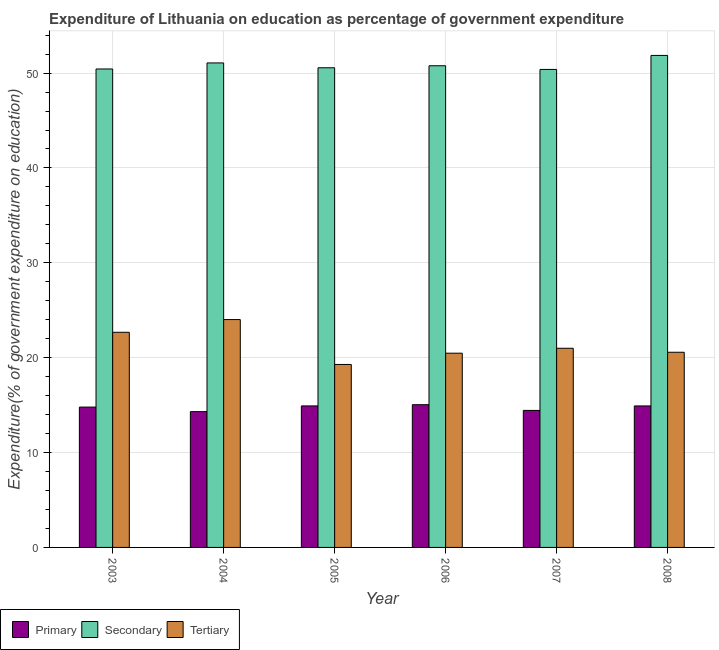How many groups of bars are there?
Ensure brevity in your answer.  6. Are the number of bars per tick equal to the number of legend labels?
Your answer should be compact. Yes. How many bars are there on the 2nd tick from the left?
Keep it short and to the point. 3. How many bars are there on the 1st tick from the right?
Your answer should be compact. 3. What is the expenditure on tertiary education in 2003?
Provide a short and direct response. 22.68. Across all years, what is the maximum expenditure on secondary education?
Provide a short and direct response. 51.86. Across all years, what is the minimum expenditure on secondary education?
Provide a succinct answer. 50.39. In which year was the expenditure on tertiary education minimum?
Make the answer very short. 2005. What is the total expenditure on primary education in the graph?
Provide a succinct answer. 88.43. What is the difference between the expenditure on tertiary education in 2003 and that in 2005?
Your response must be concise. 3.39. What is the difference between the expenditure on secondary education in 2007 and the expenditure on primary education in 2005?
Keep it short and to the point. -0.17. What is the average expenditure on secondary education per year?
Provide a succinct answer. 50.85. In how many years, is the expenditure on primary education greater than 10 %?
Offer a terse response. 6. What is the ratio of the expenditure on secondary education in 2006 to that in 2008?
Your response must be concise. 0.98. Is the expenditure on secondary education in 2007 less than that in 2008?
Give a very brief answer. Yes. Is the difference between the expenditure on primary education in 2005 and 2006 greater than the difference between the expenditure on secondary education in 2005 and 2006?
Provide a succinct answer. No. What is the difference between the highest and the second highest expenditure on primary education?
Make the answer very short. 0.13. What is the difference between the highest and the lowest expenditure on primary education?
Provide a succinct answer. 0.73. In how many years, is the expenditure on primary education greater than the average expenditure on primary education taken over all years?
Offer a very short reply. 4. Is the sum of the expenditure on secondary education in 2006 and 2007 greater than the maximum expenditure on primary education across all years?
Your answer should be very brief. Yes. What does the 1st bar from the left in 2003 represents?
Your answer should be very brief. Primary. What does the 3rd bar from the right in 2003 represents?
Your response must be concise. Primary. How many bars are there?
Your answer should be very brief. 18. Are the values on the major ticks of Y-axis written in scientific E-notation?
Give a very brief answer. No. How many legend labels are there?
Make the answer very short. 3. How are the legend labels stacked?
Ensure brevity in your answer.  Horizontal. What is the title of the graph?
Make the answer very short. Expenditure of Lithuania on education as percentage of government expenditure. What is the label or title of the Y-axis?
Provide a succinct answer. Expenditure(% of government expenditure on education). What is the Expenditure(% of government expenditure on education) of Primary in 2003?
Give a very brief answer. 14.79. What is the Expenditure(% of government expenditure on education) of Secondary in 2003?
Offer a very short reply. 50.43. What is the Expenditure(% of government expenditure on education) in Tertiary in 2003?
Give a very brief answer. 22.68. What is the Expenditure(% of government expenditure on education) in Primary in 2004?
Your response must be concise. 14.31. What is the Expenditure(% of government expenditure on education) of Secondary in 2004?
Your answer should be compact. 51.07. What is the Expenditure(% of government expenditure on education) of Tertiary in 2004?
Keep it short and to the point. 24.02. What is the Expenditure(% of government expenditure on education) of Primary in 2005?
Offer a terse response. 14.92. What is the Expenditure(% of government expenditure on education) in Secondary in 2005?
Provide a short and direct response. 50.56. What is the Expenditure(% of government expenditure on education) of Tertiary in 2005?
Keep it short and to the point. 19.29. What is the Expenditure(% of government expenditure on education) of Primary in 2006?
Offer a terse response. 15.04. What is the Expenditure(% of government expenditure on education) of Secondary in 2006?
Offer a terse response. 50.77. What is the Expenditure(% of government expenditure on education) in Tertiary in 2006?
Your answer should be very brief. 20.47. What is the Expenditure(% of government expenditure on education) in Primary in 2007?
Keep it short and to the point. 14.44. What is the Expenditure(% of government expenditure on education) in Secondary in 2007?
Ensure brevity in your answer.  50.39. What is the Expenditure(% of government expenditure on education) in Tertiary in 2007?
Provide a succinct answer. 20.99. What is the Expenditure(% of government expenditure on education) of Primary in 2008?
Your answer should be compact. 14.92. What is the Expenditure(% of government expenditure on education) of Secondary in 2008?
Give a very brief answer. 51.86. What is the Expenditure(% of government expenditure on education) of Tertiary in 2008?
Your response must be concise. 20.57. Across all years, what is the maximum Expenditure(% of government expenditure on education) of Primary?
Your answer should be compact. 15.04. Across all years, what is the maximum Expenditure(% of government expenditure on education) of Secondary?
Your answer should be very brief. 51.86. Across all years, what is the maximum Expenditure(% of government expenditure on education) of Tertiary?
Your answer should be compact. 24.02. Across all years, what is the minimum Expenditure(% of government expenditure on education) in Primary?
Your answer should be compact. 14.31. Across all years, what is the minimum Expenditure(% of government expenditure on education) of Secondary?
Provide a short and direct response. 50.39. Across all years, what is the minimum Expenditure(% of government expenditure on education) of Tertiary?
Offer a terse response. 19.29. What is the total Expenditure(% of government expenditure on education) in Primary in the graph?
Offer a terse response. 88.43. What is the total Expenditure(% of government expenditure on education) of Secondary in the graph?
Keep it short and to the point. 305.09. What is the total Expenditure(% of government expenditure on education) of Tertiary in the graph?
Make the answer very short. 128.02. What is the difference between the Expenditure(% of government expenditure on education) in Primary in 2003 and that in 2004?
Offer a terse response. 0.48. What is the difference between the Expenditure(% of government expenditure on education) in Secondary in 2003 and that in 2004?
Provide a short and direct response. -0.64. What is the difference between the Expenditure(% of government expenditure on education) of Tertiary in 2003 and that in 2004?
Offer a very short reply. -1.34. What is the difference between the Expenditure(% of government expenditure on education) in Primary in 2003 and that in 2005?
Offer a very short reply. -0.12. What is the difference between the Expenditure(% of government expenditure on education) in Secondary in 2003 and that in 2005?
Offer a terse response. -0.13. What is the difference between the Expenditure(% of government expenditure on education) of Tertiary in 2003 and that in 2005?
Make the answer very short. 3.39. What is the difference between the Expenditure(% of government expenditure on education) of Primary in 2003 and that in 2006?
Keep it short and to the point. -0.25. What is the difference between the Expenditure(% of government expenditure on education) of Secondary in 2003 and that in 2006?
Provide a short and direct response. -0.34. What is the difference between the Expenditure(% of government expenditure on education) in Tertiary in 2003 and that in 2006?
Provide a short and direct response. 2.2. What is the difference between the Expenditure(% of government expenditure on education) of Primary in 2003 and that in 2007?
Offer a terse response. 0.35. What is the difference between the Expenditure(% of government expenditure on education) of Secondary in 2003 and that in 2007?
Your answer should be compact. 0.05. What is the difference between the Expenditure(% of government expenditure on education) of Tertiary in 2003 and that in 2007?
Offer a very short reply. 1.68. What is the difference between the Expenditure(% of government expenditure on education) in Primary in 2003 and that in 2008?
Provide a short and direct response. -0.12. What is the difference between the Expenditure(% of government expenditure on education) in Secondary in 2003 and that in 2008?
Make the answer very short. -1.43. What is the difference between the Expenditure(% of government expenditure on education) in Tertiary in 2003 and that in 2008?
Keep it short and to the point. 2.1. What is the difference between the Expenditure(% of government expenditure on education) in Primary in 2004 and that in 2005?
Your answer should be very brief. -0.6. What is the difference between the Expenditure(% of government expenditure on education) in Secondary in 2004 and that in 2005?
Your answer should be very brief. 0.51. What is the difference between the Expenditure(% of government expenditure on education) of Tertiary in 2004 and that in 2005?
Ensure brevity in your answer.  4.73. What is the difference between the Expenditure(% of government expenditure on education) of Primary in 2004 and that in 2006?
Offer a very short reply. -0.73. What is the difference between the Expenditure(% of government expenditure on education) of Secondary in 2004 and that in 2006?
Keep it short and to the point. 0.3. What is the difference between the Expenditure(% of government expenditure on education) in Tertiary in 2004 and that in 2006?
Make the answer very short. 3.54. What is the difference between the Expenditure(% of government expenditure on education) in Primary in 2004 and that in 2007?
Give a very brief answer. -0.13. What is the difference between the Expenditure(% of government expenditure on education) of Secondary in 2004 and that in 2007?
Offer a very short reply. 0.68. What is the difference between the Expenditure(% of government expenditure on education) in Tertiary in 2004 and that in 2007?
Your answer should be compact. 3.02. What is the difference between the Expenditure(% of government expenditure on education) in Primary in 2004 and that in 2008?
Offer a terse response. -0.6. What is the difference between the Expenditure(% of government expenditure on education) of Secondary in 2004 and that in 2008?
Provide a short and direct response. -0.79. What is the difference between the Expenditure(% of government expenditure on education) in Tertiary in 2004 and that in 2008?
Give a very brief answer. 3.45. What is the difference between the Expenditure(% of government expenditure on education) of Primary in 2005 and that in 2006?
Provide a succinct answer. -0.13. What is the difference between the Expenditure(% of government expenditure on education) in Secondary in 2005 and that in 2006?
Provide a succinct answer. -0.21. What is the difference between the Expenditure(% of government expenditure on education) in Tertiary in 2005 and that in 2006?
Give a very brief answer. -1.19. What is the difference between the Expenditure(% of government expenditure on education) of Primary in 2005 and that in 2007?
Your answer should be very brief. 0.47. What is the difference between the Expenditure(% of government expenditure on education) of Secondary in 2005 and that in 2007?
Offer a very short reply. 0.17. What is the difference between the Expenditure(% of government expenditure on education) of Tertiary in 2005 and that in 2007?
Provide a succinct answer. -1.71. What is the difference between the Expenditure(% of government expenditure on education) of Primary in 2005 and that in 2008?
Ensure brevity in your answer.  0. What is the difference between the Expenditure(% of government expenditure on education) in Secondary in 2005 and that in 2008?
Keep it short and to the point. -1.3. What is the difference between the Expenditure(% of government expenditure on education) in Tertiary in 2005 and that in 2008?
Provide a short and direct response. -1.29. What is the difference between the Expenditure(% of government expenditure on education) of Primary in 2006 and that in 2007?
Ensure brevity in your answer.  0.6. What is the difference between the Expenditure(% of government expenditure on education) of Secondary in 2006 and that in 2007?
Keep it short and to the point. 0.39. What is the difference between the Expenditure(% of government expenditure on education) of Tertiary in 2006 and that in 2007?
Your response must be concise. -0.52. What is the difference between the Expenditure(% of government expenditure on education) in Primary in 2006 and that in 2008?
Provide a short and direct response. 0.13. What is the difference between the Expenditure(% of government expenditure on education) of Secondary in 2006 and that in 2008?
Provide a succinct answer. -1.09. What is the difference between the Expenditure(% of government expenditure on education) of Tertiary in 2006 and that in 2008?
Keep it short and to the point. -0.1. What is the difference between the Expenditure(% of government expenditure on education) in Primary in 2007 and that in 2008?
Provide a succinct answer. -0.47. What is the difference between the Expenditure(% of government expenditure on education) of Secondary in 2007 and that in 2008?
Provide a short and direct response. -1.48. What is the difference between the Expenditure(% of government expenditure on education) in Tertiary in 2007 and that in 2008?
Offer a very short reply. 0.42. What is the difference between the Expenditure(% of government expenditure on education) in Primary in 2003 and the Expenditure(% of government expenditure on education) in Secondary in 2004?
Provide a short and direct response. -36.28. What is the difference between the Expenditure(% of government expenditure on education) of Primary in 2003 and the Expenditure(% of government expenditure on education) of Tertiary in 2004?
Ensure brevity in your answer.  -9.22. What is the difference between the Expenditure(% of government expenditure on education) in Secondary in 2003 and the Expenditure(% of government expenditure on education) in Tertiary in 2004?
Provide a succinct answer. 26.42. What is the difference between the Expenditure(% of government expenditure on education) in Primary in 2003 and the Expenditure(% of government expenditure on education) in Secondary in 2005?
Your answer should be compact. -35.77. What is the difference between the Expenditure(% of government expenditure on education) of Primary in 2003 and the Expenditure(% of government expenditure on education) of Tertiary in 2005?
Offer a very short reply. -4.49. What is the difference between the Expenditure(% of government expenditure on education) in Secondary in 2003 and the Expenditure(% of government expenditure on education) in Tertiary in 2005?
Your answer should be compact. 31.15. What is the difference between the Expenditure(% of government expenditure on education) in Primary in 2003 and the Expenditure(% of government expenditure on education) in Secondary in 2006?
Your answer should be compact. -35.98. What is the difference between the Expenditure(% of government expenditure on education) in Primary in 2003 and the Expenditure(% of government expenditure on education) in Tertiary in 2006?
Provide a short and direct response. -5.68. What is the difference between the Expenditure(% of government expenditure on education) of Secondary in 2003 and the Expenditure(% of government expenditure on education) of Tertiary in 2006?
Keep it short and to the point. 29.96. What is the difference between the Expenditure(% of government expenditure on education) of Primary in 2003 and the Expenditure(% of government expenditure on education) of Secondary in 2007?
Your answer should be very brief. -35.59. What is the difference between the Expenditure(% of government expenditure on education) in Primary in 2003 and the Expenditure(% of government expenditure on education) in Tertiary in 2007?
Your answer should be very brief. -6.2. What is the difference between the Expenditure(% of government expenditure on education) in Secondary in 2003 and the Expenditure(% of government expenditure on education) in Tertiary in 2007?
Your response must be concise. 29.44. What is the difference between the Expenditure(% of government expenditure on education) of Primary in 2003 and the Expenditure(% of government expenditure on education) of Secondary in 2008?
Give a very brief answer. -37.07. What is the difference between the Expenditure(% of government expenditure on education) of Primary in 2003 and the Expenditure(% of government expenditure on education) of Tertiary in 2008?
Give a very brief answer. -5.78. What is the difference between the Expenditure(% of government expenditure on education) of Secondary in 2003 and the Expenditure(% of government expenditure on education) of Tertiary in 2008?
Ensure brevity in your answer.  29.86. What is the difference between the Expenditure(% of government expenditure on education) in Primary in 2004 and the Expenditure(% of government expenditure on education) in Secondary in 2005?
Your answer should be compact. -36.25. What is the difference between the Expenditure(% of government expenditure on education) in Primary in 2004 and the Expenditure(% of government expenditure on education) in Tertiary in 2005?
Keep it short and to the point. -4.97. What is the difference between the Expenditure(% of government expenditure on education) of Secondary in 2004 and the Expenditure(% of government expenditure on education) of Tertiary in 2005?
Give a very brief answer. 31.78. What is the difference between the Expenditure(% of government expenditure on education) in Primary in 2004 and the Expenditure(% of government expenditure on education) in Secondary in 2006?
Your answer should be very brief. -36.46. What is the difference between the Expenditure(% of government expenditure on education) in Primary in 2004 and the Expenditure(% of government expenditure on education) in Tertiary in 2006?
Ensure brevity in your answer.  -6.16. What is the difference between the Expenditure(% of government expenditure on education) of Secondary in 2004 and the Expenditure(% of government expenditure on education) of Tertiary in 2006?
Your response must be concise. 30.6. What is the difference between the Expenditure(% of government expenditure on education) in Primary in 2004 and the Expenditure(% of government expenditure on education) in Secondary in 2007?
Offer a terse response. -36.07. What is the difference between the Expenditure(% of government expenditure on education) of Primary in 2004 and the Expenditure(% of government expenditure on education) of Tertiary in 2007?
Your answer should be very brief. -6.68. What is the difference between the Expenditure(% of government expenditure on education) of Secondary in 2004 and the Expenditure(% of government expenditure on education) of Tertiary in 2007?
Your response must be concise. 30.08. What is the difference between the Expenditure(% of government expenditure on education) of Primary in 2004 and the Expenditure(% of government expenditure on education) of Secondary in 2008?
Provide a succinct answer. -37.55. What is the difference between the Expenditure(% of government expenditure on education) in Primary in 2004 and the Expenditure(% of government expenditure on education) in Tertiary in 2008?
Provide a succinct answer. -6.26. What is the difference between the Expenditure(% of government expenditure on education) in Secondary in 2004 and the Expenditure(% of government expenditure on education) in Tertiary in 2008?
Your response must be concise. 30.5. What is the difference between the Expenditure(% of government expenditure on education) of Primary in 2005 and the Expenditure(% of government expenditure on education) of Secondary in 2006?
Your answer should be very brief. -35.86. What is the difference between the Expenditure(% of government expenditure on education) in Primary in 2005 and the Expenditure(% of government expenditure on education) in Tertiary in 2006?
Your answer should be very brief. -5.56. What is the difference between the Expenditure(% of government expenditure on education) in Secondary in 2005 and the Expenditure(% of government expenditure on education) in Tertiary in 2006?
Give a very brief answer. 30.09. What is the difference between the Expenditure(% of government expenditure on education) in Primary in 2005 and the Expenditure(% of government expenditure on education) in Secondary in 2007?
Ensure brevity in your answer.  -35.47. What is the difference between the Expenditure(% of government expenditure on education) in Primary in 2005 and the Expenditure(% of government expenditure on education) in Tertiary in 2007?
Provide a succinct answer. -6.08. What is the difference between the Expenditure(% of government expenditure on education) of Secondary in 2005 and the Expenditure(% of government expenditure on education) of Tertiary in 2007?
Your response must be concise. 29.57. What is the difference between the Expenditure(% of government expenditure on education) of Primary in 2005 and the Expenditure(% of government expenditure on education) of Secondary in 2008?
Keep it short and to the point. -36.95. What is the difference between the Expenditure(% of government expenditure on education) in Primary in 2005 and the Expenditure(% of government expenditure on education) in Tertiary in 2008?
Offer a very short reply. -5.66. What is the difference between the Expenditure(% of government expenditure on education) in Secondary in 2005 and the Expenditure(% of government expenditure on education) in Tertiary in 2008?
Ensure brevity in your answer.  29.99. What is the difference between the Expenditure(% of government expenditure on education) of Primary in 2006 and the Expenditure(% of government expenditure on education) of Secondary in 2007?
Make the answer very short. -35.34. What is the difference between the Expenditure(% of government expenditure on education) in Primary in 2006 and the Expenditure(% of government expenditure on education) in Tertiary in 2007?
Keep it short and to the point. -5.95. What is the difference between the Expenditure(% of government expenditure on education) in Secondary in 2006 and the Expenditure(% of government expenditure on education) in Tertiary in 2007?
Your answer should be compact. 29.78. What is the difference between the Expenditure(% of government expenditure on education) of Primary in 2006 and the Expenditure(% of government expenditure on education) of Secondary in 2008?
Give a very brief answer. -36.82. What is the difference between the Expenditure(% of government expenditure on education) of Primary in 2006 and the Expenditure(% of government expenditure on education) of Tertiary in 2008?
Give a very brief answer. -5.53. What is the difference between the Expenditure(% of government expenditure on education) of Secondary in 2006 and the Expenditure(% of government expenditure on education) of Tertiary in 2008?
Give a very brief answer. 30.2. What is the difference between the Expenditure(% of government expenditure on education) of Primary in 2007 and the Expenditure(% of government expenditure on education) of Secondary in 2008?
Your response must be concise. -37.42. What is the difference between the Expenditure(% of government expenditure on education) of Primary in 2007 and the Expenditure(% of government expenditure on education) of Tertiary in 2008?
Provide a short and direct response. -6.13. What is the difference between the Expenditure(% of government expenditure on education) of Secondary in 2007 and the Expenditure(% of government expenditure on education) of Tertiary in 2008?
Offer a terse response. 29.81. What is the average Expenditure(% of government expenditure on education) in Primary per year?
Give a very brief answer. 14.74. What is the average Expenditure(% of government expenditure on education) in Secondary per year?
Offer a very short reply. 50.85. What is the average Expenditure(% of government expenditure on education) in Tertiary per year?
Give a very brief answer. 21.34. In the year 2003, what is the difference between the Expenditure(% of government expenditure on education) in Primary and Expenditure(% of government expenditure on education) in Secondary?
Provide a short and direct response. -35.64. In the year 2003, what is the difference between the Expenditure(% of government expenditure on education) of Primary and Expenditure(% of government expenditure on education) of Tertiary?
Provide a succinct answer. -7.88. In the year 2003, what is the difference between the Expenditure(% of government expenditure on education) of Secondary and Expenditure(% of government expenditure on education) of Tertiary?
Your response must be concise. 27.76. In the year 2004, what is the difference between the Expenditure(% of government expenditure on education) in Primary and Expenditure(% of government expenditure on education) in Secondary?
Give a very brief answer. -36.76. In the year 2004, what is the difference between the Expenditure(% of government expenditure on education) of Primary and Expenditure(% of government expenditure on education) of Tertiary?
Make the answer very short. -9.7. In the year 2004, what is the difference between the Expenditure(% of government expenditure on education) in Secondary and Expenditure(% of government expenditure on education) in Tertiary?
Keep it short and to the point. 27.05. In the year 2005, what is the difference between the Expenditure(% of government expenditure on education) of Primary and Expenditure(% of government expenditure on education) of Secondary?
Keep it short and to the point. -35.64. In the year 2005, what is the difference between the Expenditure(% of government expenditure on education) of Primary and Expenditure(% of government expenditure on education) of Tertiary?
Provide a succinct answer. -4.37. In the year 2005, what is the difference between the Expenditure(% of government expenditure on education) in Secondary and Expenditure(% of government expenditure on education) in Tertiary?
Your response must be concise. 31.27. In the year 2006, what is the difference between the Expenditure(% of government expenditure on education) in Primary and Expenditure(% of government expenditure on education) in Secondary?
Keep it short and to the point. -35.73. In the year 2006, what is the difference between the Expenditure(% of government expenditure on education) of Primary and Expenditure(% of government expenditure on education) of Tertiary?
Keep it short and to the point. -5.43. In the year 2006, what is the difference between the Expenditure(% of government expenditure on education) in Secondary and Expenditure(% of government expenditure on education) in Tertiary?
Ensure brevity in your answer.  30.3. In the year 2007, what is the difference between the Expenditure(% of government expenditure on education) in Primary and Expenditure(% of government expenditure on education) in Secondary?
Offer a terse response. -35.94. In the year 2007, what is the difference between the Expenditure(% of government expenditure on education) of Primary and Expenditure(% of government expenditure on education) of Tertiary?
Keep it short and to the point. -6.55. In the year 2007, what is the difference between the Expenditure(% of government expenditure on education) of Secondary and Expenditure(% of government expenditure on education) of Tertiary?
Keep it short and to the point. 29.39. In the year 2008, what is the difference between the Expenditure(% of government expenditure on education) of Primary and Expenditure(% of government expenditure on education) of Secondary?
Keep it short and to the point. -36.95. In the year 2008, what is the difference between the Expenditure(% of government expenditure on education) of Primary and Expenditure(% of government expenditure on education) of Tertiary?
Ensure brevity in your answer.  -5.66. In the year 2008, what is the difference between the Expenditure(% of government expenditure on education) in Secondary and Expenditure(% of government expenditure on education) in Tertiary?
Your answer should be compact. 31.29. What is the ratio of the Expenditure(% of government expenditure on education) in Primary in 2003 to that in 2004?
Offer a very short reply. 1.03. What is the ratio of the Expenditure(% of government expenditure on education) in Secondary in 2003 to that in 2004?
Make the answer very short. 0.99. What is the ratio of the Expenditure(% of government expenditure on education) in Tertiary in 2003 to that in 2004?
Offer a very short reply. 0.94. What is the ratio of the Expenditure(% of government expenditure on education) of Tertiary in 2003 to that in 2005?
Give a very brief answer. 1.18. What is the ratio of the Expenditure(% of government expenditure on education) of Primary in 2003 to that in 2006?
Ensure brevity in your answer.  0.98. What is the ratio of the Expenditure(% of government expenditure on education) of Tertiary in 2003 to that in 2006?
Offer a very short reply. 1.11. What is the ratio of the Expenditure(% of government expenditure on education) of Primary in 2003 to that in 2007?
Offer a terse response. 1.02. What is the ratio of the Expenditure(% of government expenditure on education) in Tertiary in 2003 to that in 2007?
Keep it short and to the point. 1.08. What is the ratio of the Expenditure(% of government expenditure on education) of Primary in 2003 to that in 2008?
Make the answer very short. 0.99. What is the ratio of the Expenditure(% of government expenditure on education) in Secondary in 2003 to that in 2008?
Your answer should be very brief. 0.97. What is the ratio of the Expenditure(% of government expenditure on education) in Tertiary in 2003 to that in 2008?
Your answer should be very brief. 1.1. What is the ratio of the Expenditure(% of government expenditure on education) of Primary in 2004 to that in 2005?
Provide a short and direct response. 0.96. What is the ratio of the Expenditure(% of government expenditure on education) of Tertiary in 2004 to that in 2005?
Provide a short and direct response. 1.25. What is the ratio of the Expenditure(% of government expenditure on education) in Primary in 2004 to that in 2006?
Provide a short and direct response. 0.95. What is the ratio of the Expenditure(% of government expenditure on education) of Secondary in 2004 to that in 2006?
Provide a succinct answer. 1.01. What is the ratio of the Expenditure(% of government expenditure on education) in Tertiary in 2004 to that in 2006?
Keep it short and to the point. 1.17. What is the ratio of the Expenditure(% of government expenditure on education) in Primary in 2004 to that in 2007?
Offer a terse response. 0.99. What is the ratio of the Expenditure(% of government expenditure on education) in Secondary in 2004 to that in 2007?
Keep it short and to the point. 1.01. What is the ratio of the Expenditure(% of government expenditure on education) in Tertiary in 2004 to that in 2007?
Offer a terse response. 1.14. What is the ratio of the Expenditure(% of government expenditure on education) in Primary in 2004 to that in 2008?
Provide a succinct answer. 0.96. What is the ratio of the Expenditure(% of government expenditure on education) of Secondary in 2004 to that in 2008?
Ensure brevity in your answer.  0.98. What is the ratio of the Expenditure(% of government expenditure on education) in Tertiary in 2004 to that in 2008?
Your answer should be compact. 1.17. What is the ratio of the Expenditure(% of government expenditure on education) of Secondary in 2005 to that in 2006?
Offer a terse response. 1. What is the ratio of the Expenditure(% of government expenditure on education) of Tertiary in 2005 to that in 2006?
Provide a short and direct response. 0.94. What is the ratio of the Expenditure(% of government expenditure on education) of Primary in 2005 to that in 2007?
Ensure brevity in your answer.  1.03. What is the ratio of the Expenditure(% of government expenditure on education) of Tertiary in 2005 to that in 2007?
Provide a short and direct response. 0.92. What is the ratio of the Expenditure(% of government expenditure on education) of Primary in 2005 to that in 2008?
Offer a terse response. 1. What is the ratio of the Expenditure(% of government expenditure on education) of Secondary in 2005 to that in 2008?
Offer a very short reply. 0.97. What is the ratio of the Expenditure(% of government expenditure on education) in Primary in 2006 to that in 2007?
Provide a succinct answer. 1.04. What is the ratio of the Expenditure(% of government expenditure on education) in Secondary in 2006 to that in 2007?
Give a very brief answer. 1.01. What is the ratio of the Expenditure(% of government expenditure on education) of Tertiary in 2006 to that in 2007?
Your response must be concise. 0.98. What is the ratio of the Expenditure(% of government expenditure on education) in Primary in 2006 to that in 2008?
Make the answer very short. 1.01. What is the ratio of the Expenditure(% of government expenditure on education) of Tertiary in 2006 to that in 2008?
Provide a short and direct response. 1. What is the ratio of the Expenditure(% of government expenditure on education) in Primary in 2007 to that in 2008?
Your answer should be compact. 0.97. What is the ratio of the Expenditure(% of government expenditure on education) in Secondary in 2007 to that in 2008?
Provide a succinct answer. 0.97. What is the ratio of the Expenditure(% of government expenditure on education) of Tertiary in 2007 to that in 2008?
Provide a succinct answer. 1.02. What is the difference between the highest and the second highest Expenditure(% of government expenditure on education) in Primary?
Offer a terse response. 0.13. What is the difference between the highest and the second highest Expenditure(% of government expenditure on education) in Secondary?
Provide a succinct answer. 0.79. What is the difference between the highest and the second highest Expenditure(% of government expenditure on education) of Tertiary?
Your answer should be compact. 1.34. What is the difference between the highest and the lowest Expenditure(% of government expenditure on education) in Primary?
Your answer should be compact. 0.73. What is the difference between the highest and the lowest Expenditure(% of government expenditure on education) of Secondary?
Offer a very short reply. 1.48. What is the difference between the highest and the lowest Expenditure(% of government expenditure on education) of Tertiary?
Offer a very short reply. 4.73. 